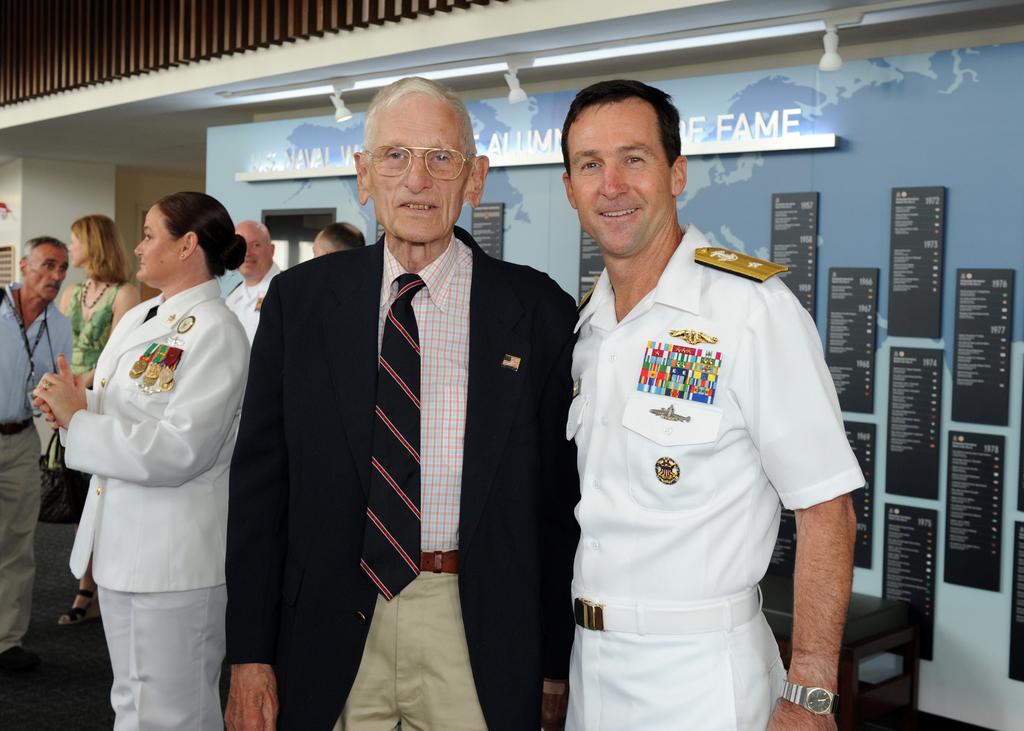What is the word behind the dark-haired man's head and to the right?
Ensure brevity in your answer.  Fame. 